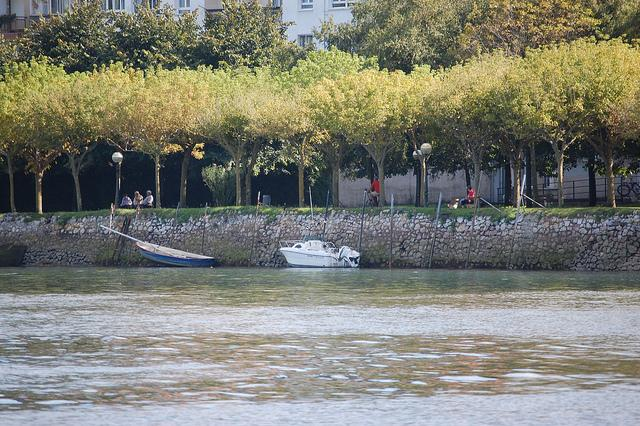What is the black rectangular object in front of the blue boat?

Choices:
A) pole
B) hose
C) fence
D) ladder ladder 